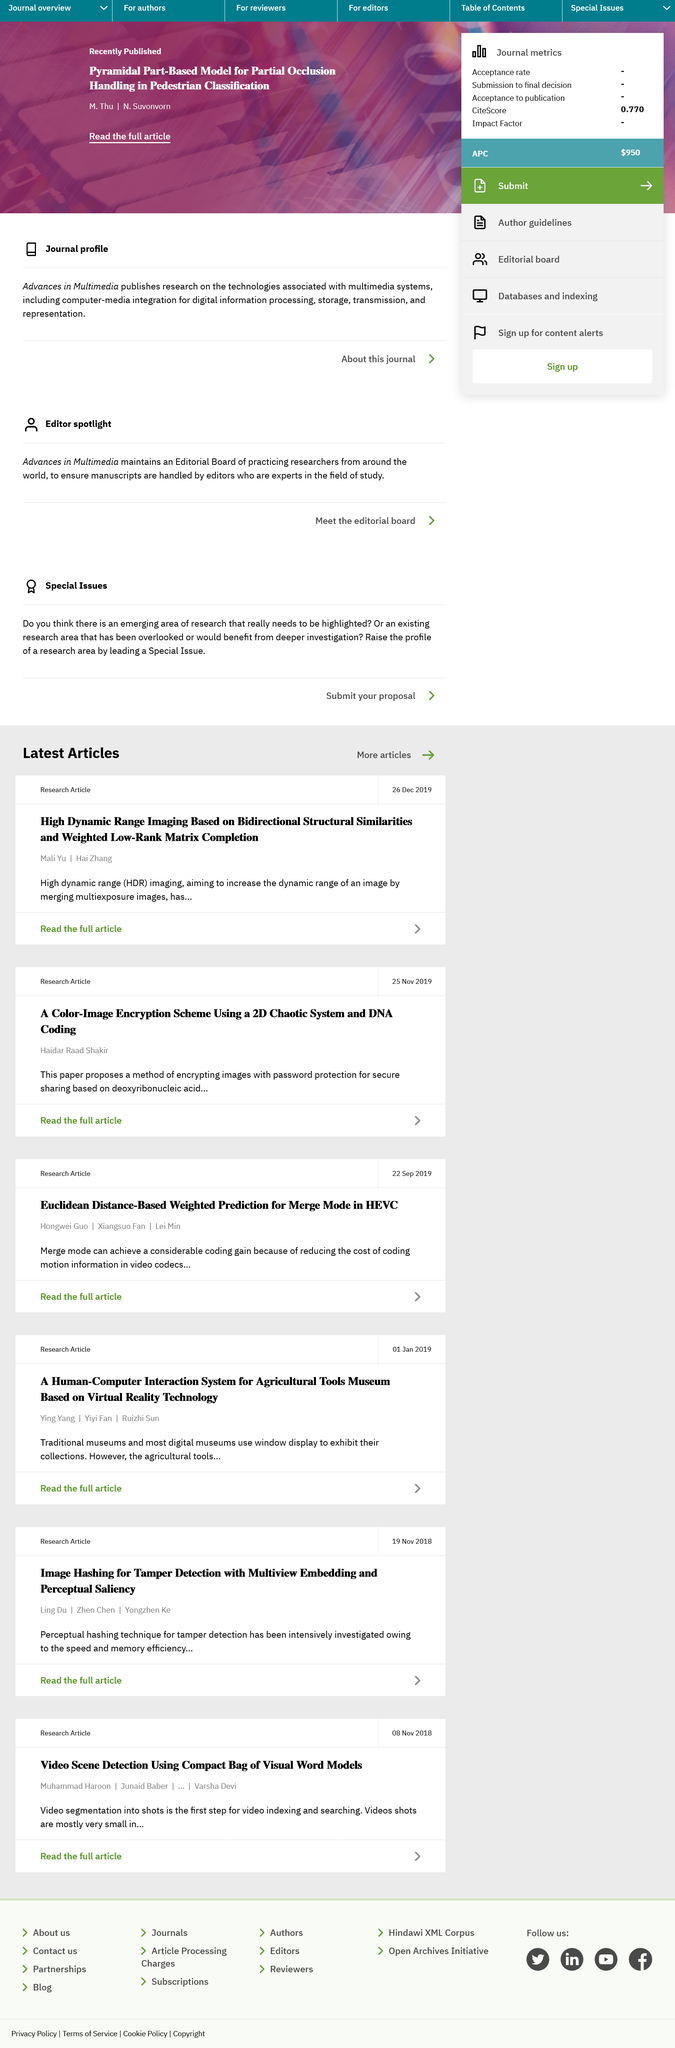Specify some key components in this picture. High dynamic range imaging, also known as HDR imaging, is a technique that produces high-quality images with a wide range of contrast and color. HDR imaging is used in a variety of applications, including photography, film, and video, to create realistic and vivid images that can better represent the actual scene. Mai Yu and Hai Zhang were the authors of the paper titled "High Dynamic Range Imaging Based on Bidirectional Structural Similarities and Weighted Low-Rank Matrix Completion". The research article titled "A Color-Image Encryption Scheme Using a 2D Chaotic System and DNA Coding?" was written by Haidar Raad Shakir. 